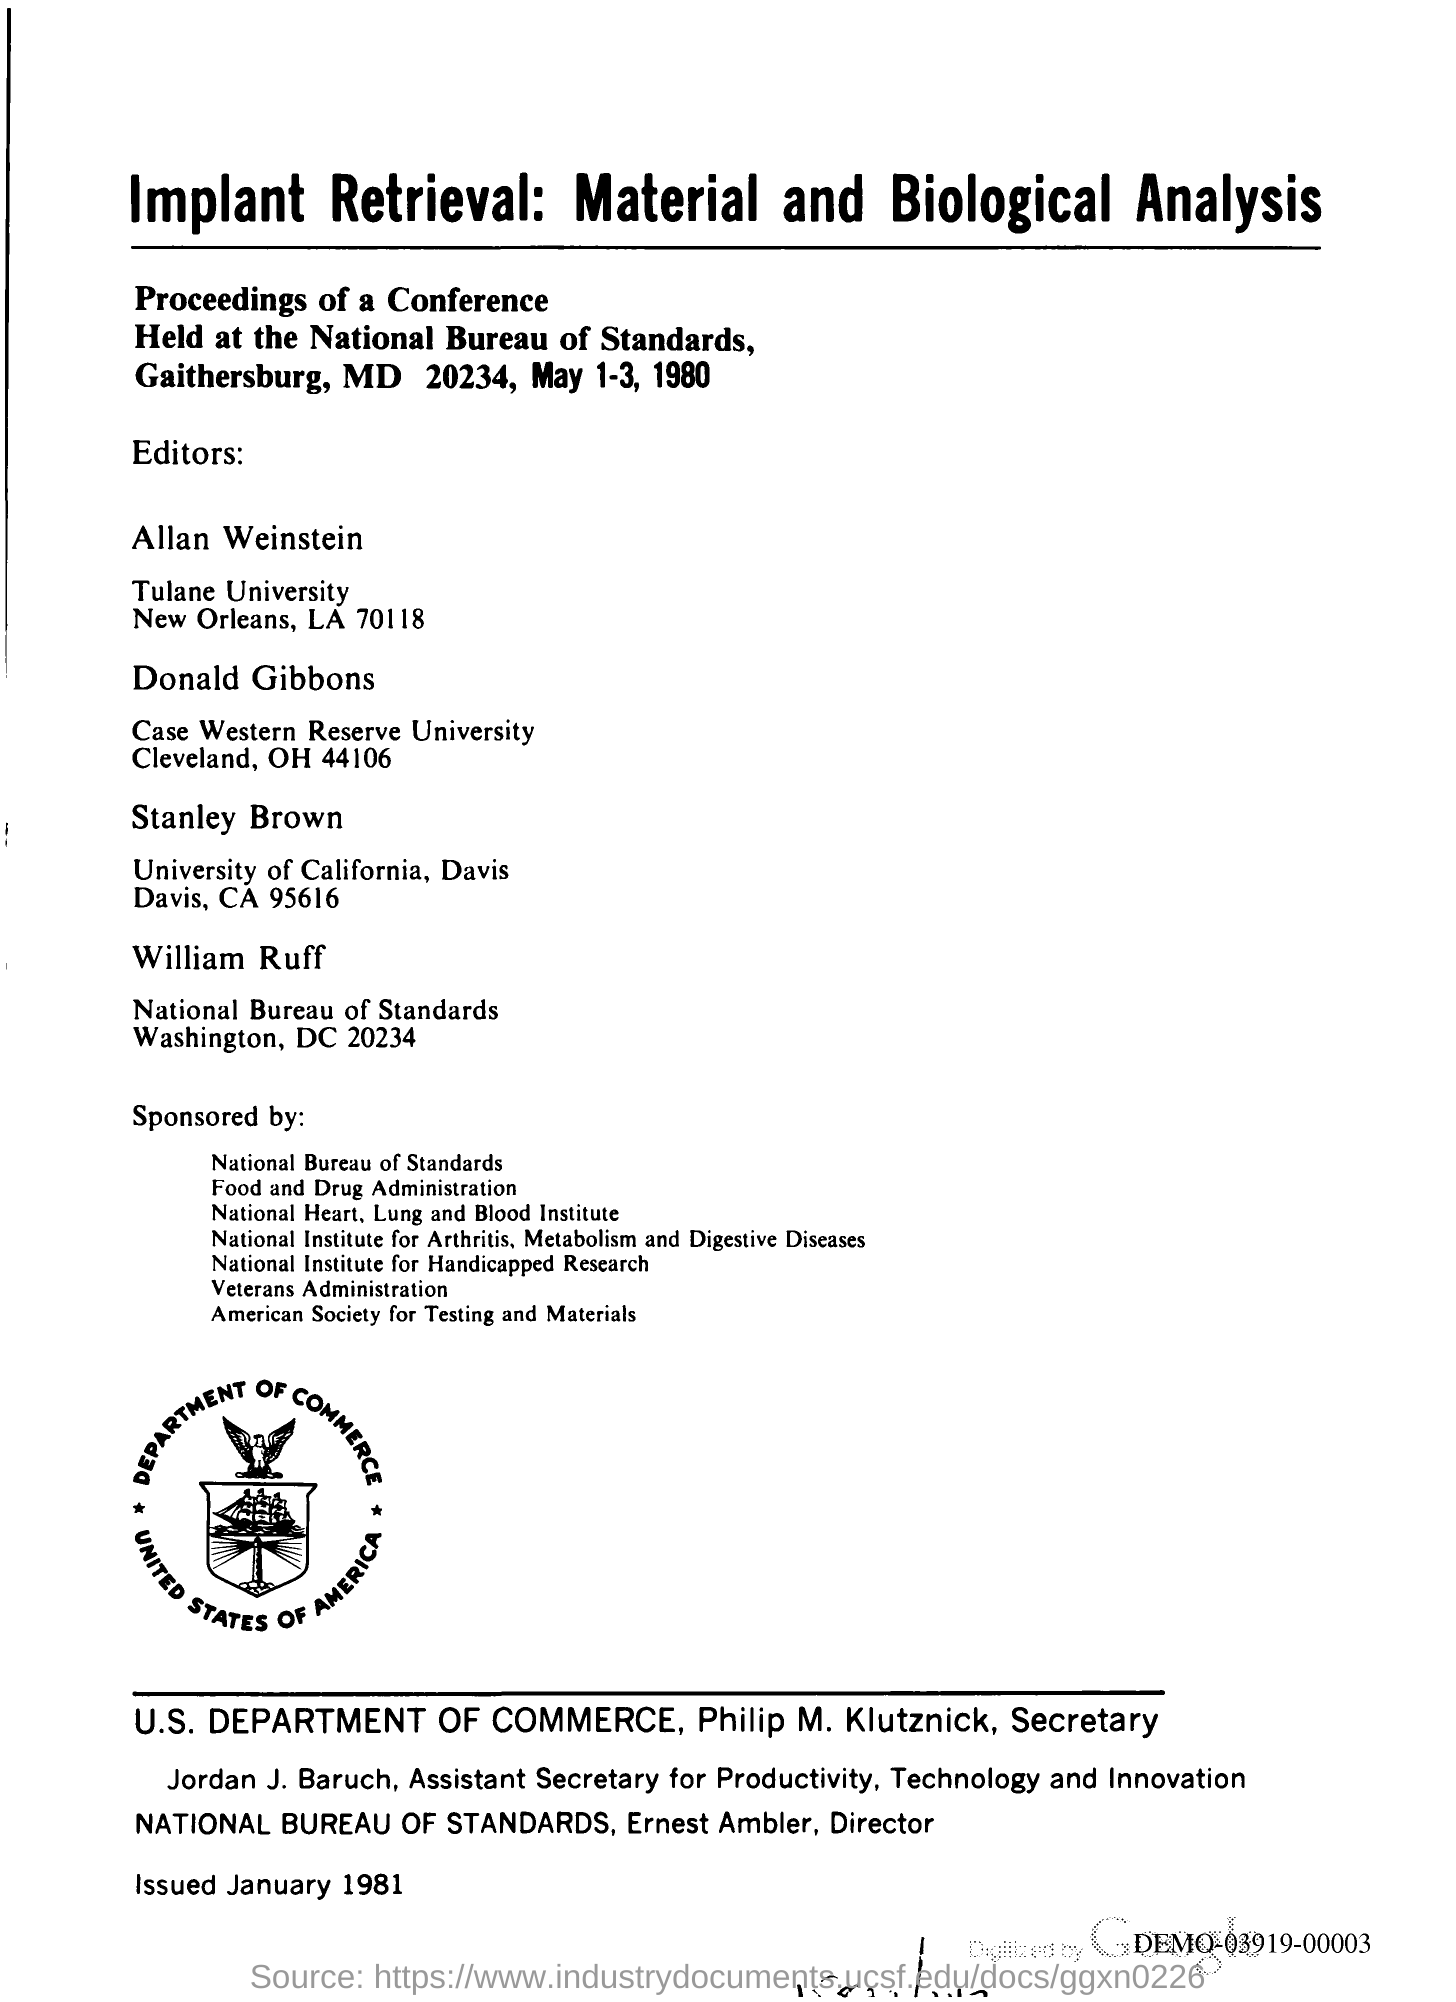Where was the conference held?
Your answer should be compact. GAITHERSBURG. 